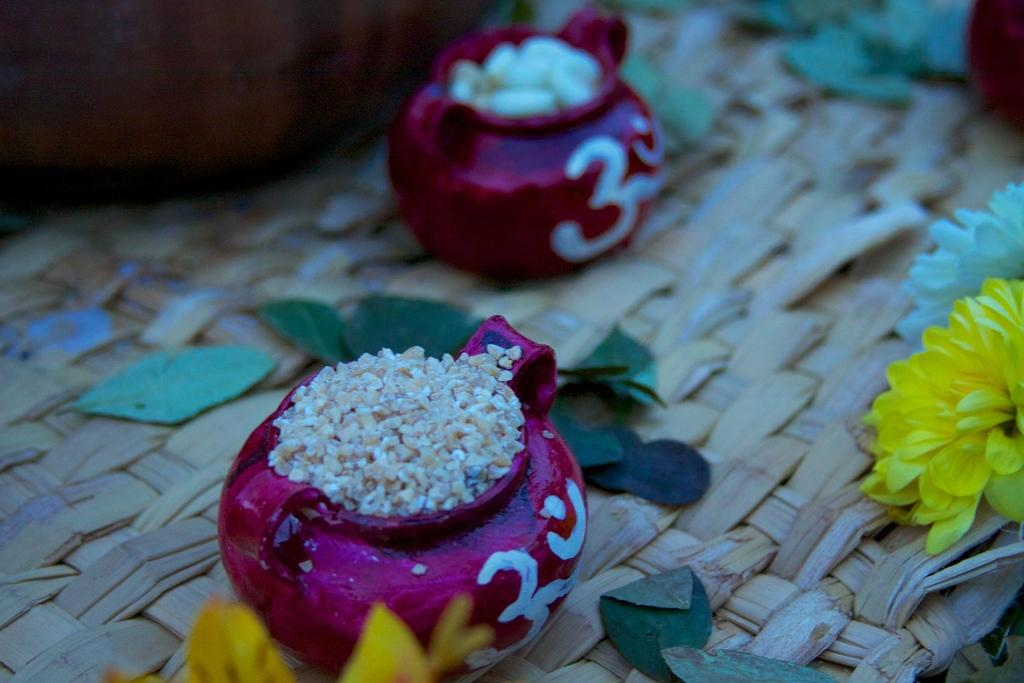What type of objects can be seen in the image? There are two colorful pots in the image. What is inside the pots? There are objects inside the pots. How are the pots positioned in the image? The pots are placed on a wooden mat. What type of natural elements are present in the image? There are leaves and flowers in the image. What type of cactus can be seen growing on the authority figure in the image? There is no cactus or authority figure present in the image. What type of brass material is used to create the objects inside the pots? The provided facts do not mention the material of the objects inside the pots, so we cannot determine if brass is used. 